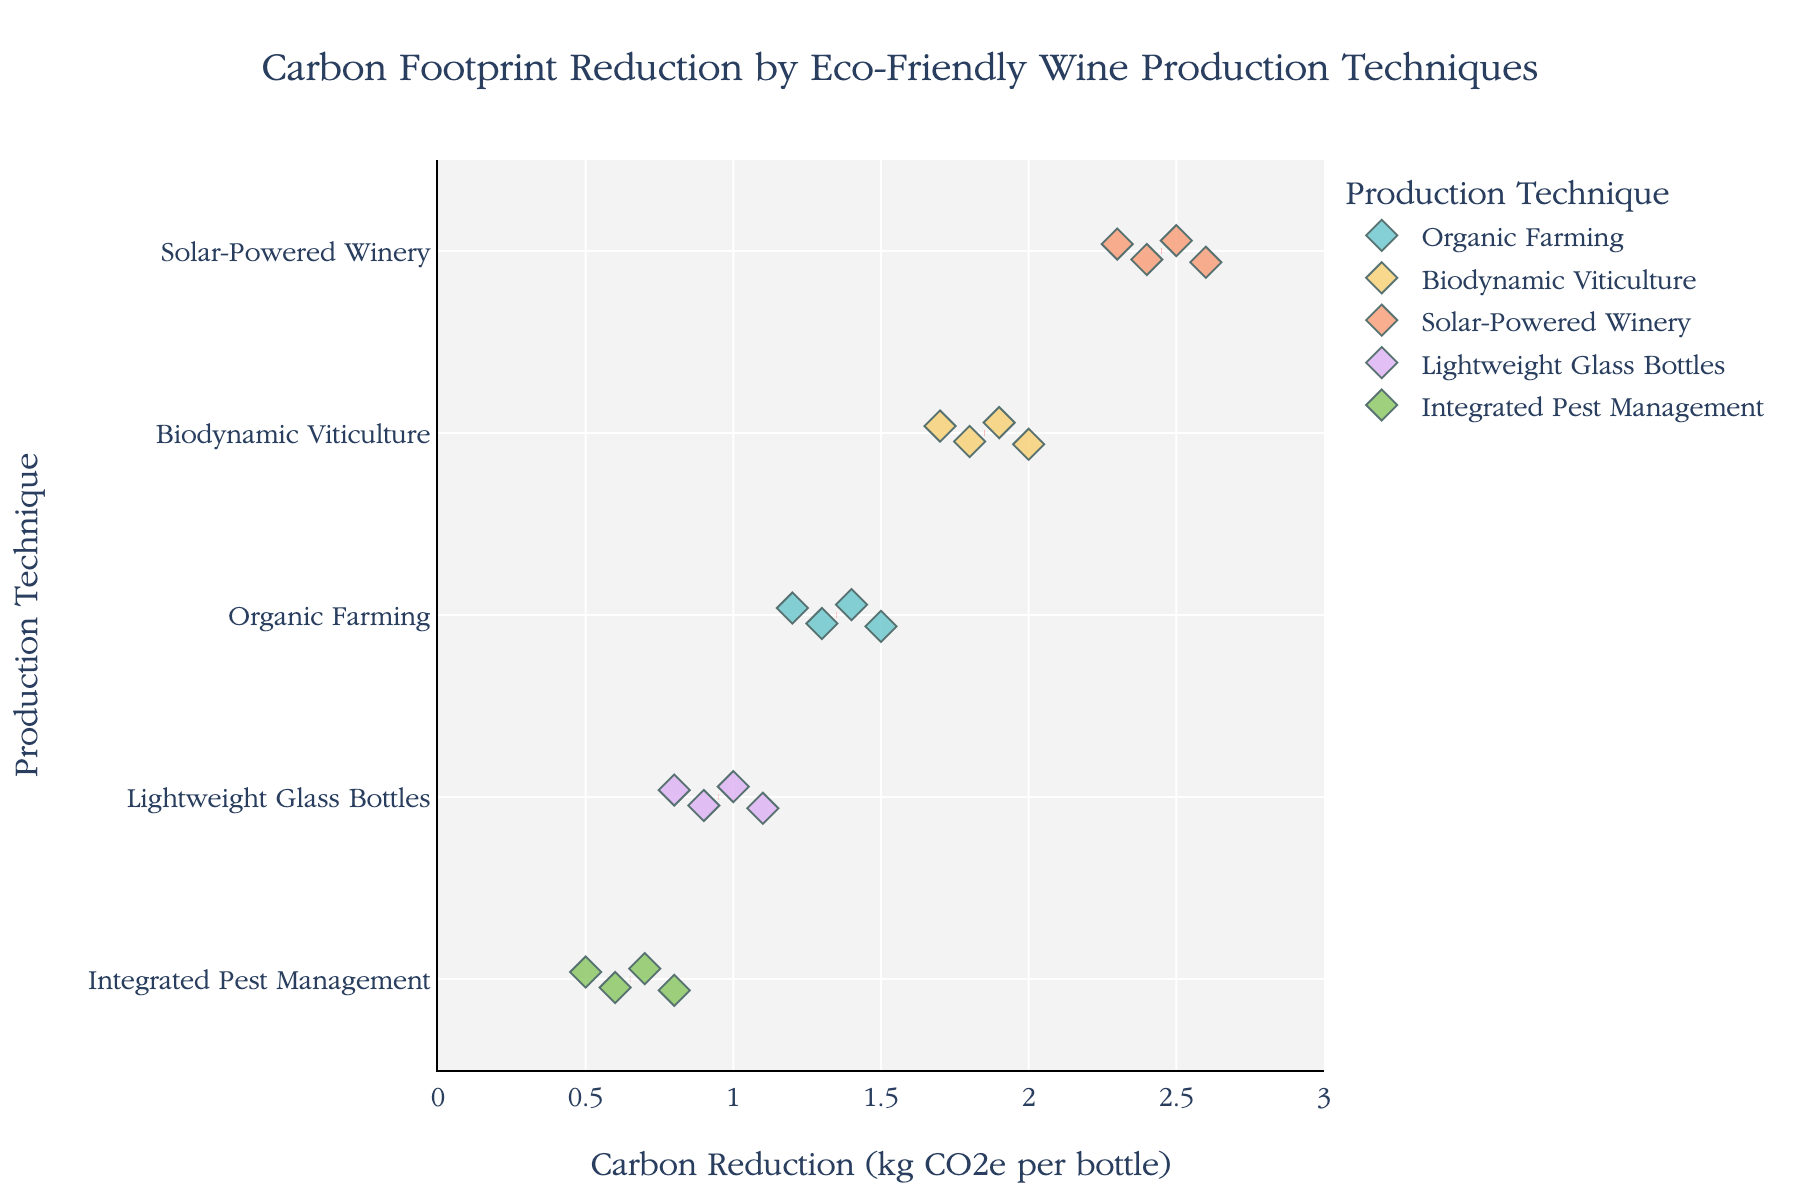How many techniques are displayed in the figure? The figure shows different eco-friendly wine production techniques on the y-axis, differentiable by the color and text labels of each horizontal strip. Count these labels for the total number of techniques.
Answer: 5 Which technique shows the highest carbon reduction per bottle? Observe the x-axis values and the corresponding techniques to find the highest point. Look for the technique with the data points farthest to the right.
Answer: Solar-Powered Winery What is the mean carbon reduction value for Organic Farming? The figure uses red dashed lines to show mean values. Identify the red dashed line corresponding to Organic Farming on the y-axis and read the carbon reduction value on the x-axis.
Answer: 1.35 kg CO2e per bottle Compare the mean carbon reduction values of Solar-Powered Winery and Lightweight Glass Bottles. Which one is higher and by how much? Locate the red dashed lines for both Solar-Powered Winery and Lightweight Glass Bottles. Note their x-axis positions and subtract the smaller mean from the larger mean.
Answer: Solar-Powered Winery is higher by around 1.4 kg CO2e per bottle Which technique has the least spread in carbon reduction values? Observe the compactness of data points along the x-axis for each technique on the y-axis. Identify the technique whose data points are closest to each other.
Answer: Integrated Pest Management Are there any overlapping data points between Solar-Powered Winery and Biodynamic Viticulture? Check if any data points for Solar-Powered Winery and Biodynamic Viticulture align vertically on the x-axis, meaning they share similar carbon reduction values.
Answer: No What is the range of carbon reduction values for Integrated Pest Management? Identify the minimum and maximum x-axis values for Integrated Pest Management's data points, then calculate their difference.
Answer: 0.3 kg CO2e per bottle Rank the techniques from the highest to lowest mean carbon reduction. Examine the red dashed lines representing mean values for each technique on the x-axis and list them in descending order.
Answer: Solar-Powered Winery, Biodynamic Viticulture, Organic Farming, Lightweight Glass Bottles, Integrated Pest Management How many data points correspond to each technique? Count the number of individual data points (small diamond markers) plotted for each technique on the y-axis.
Answer: 4 data points per technique 